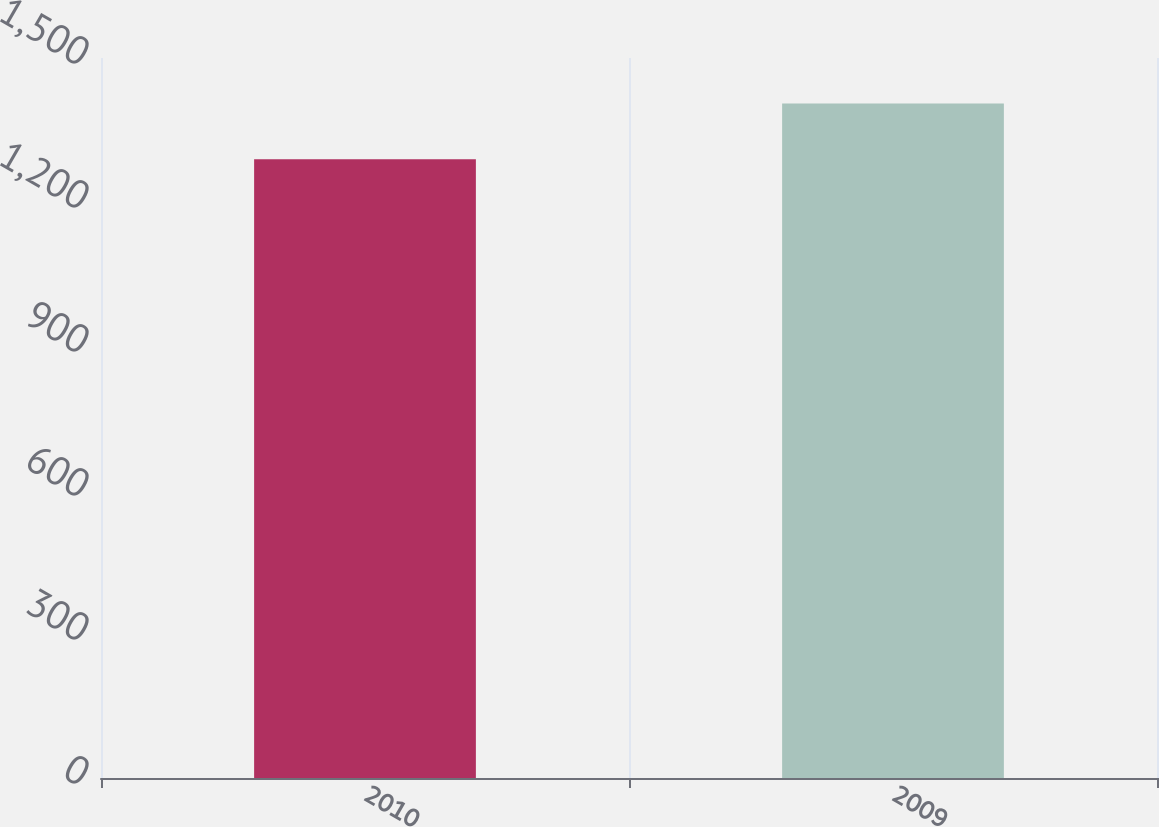Convert chart to OTSL. <chart><loc_0><loc_0><loc_500><loc_500><bar_chart><fcel>2010<fcel>2009<nl><fcel>1289<fcel>1405.3<nl></chart> 